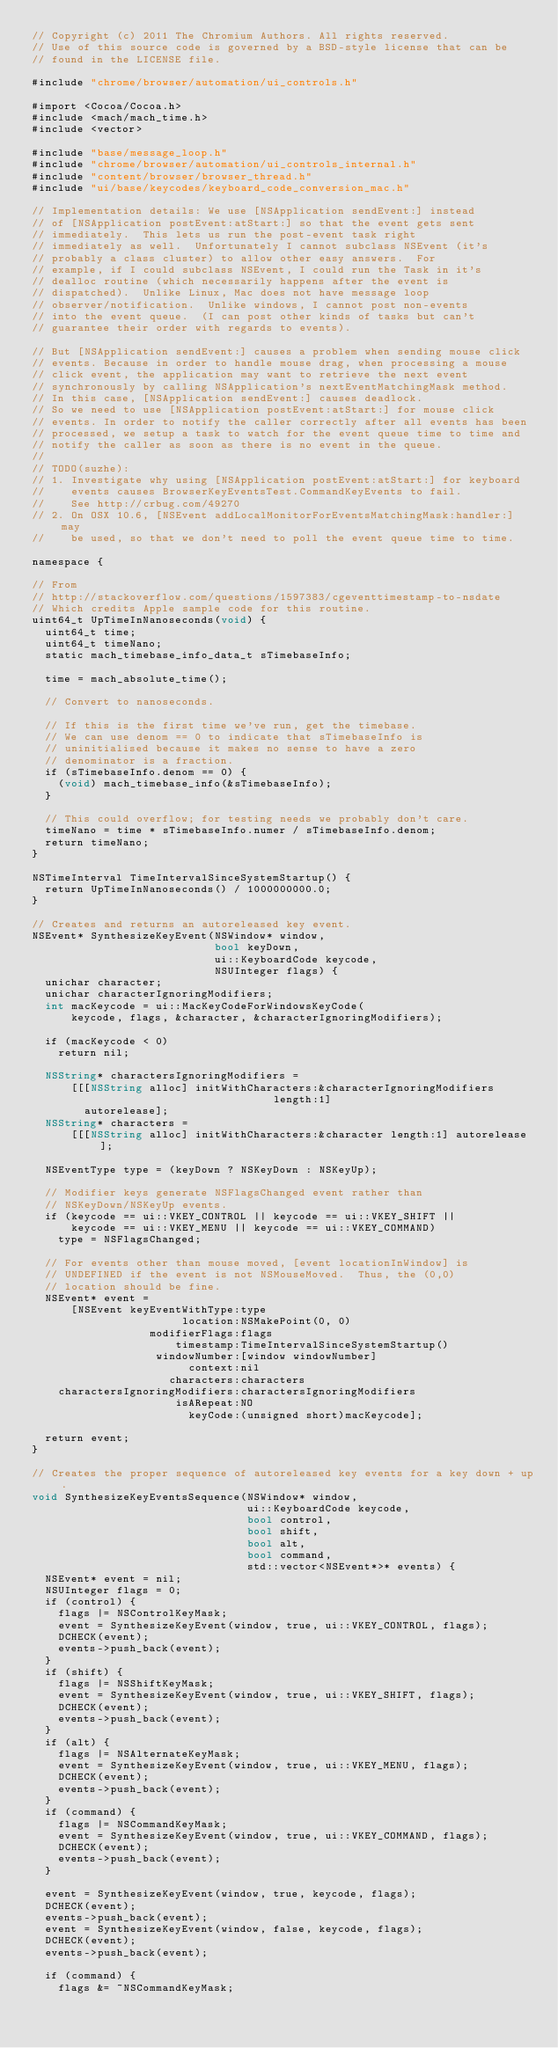Convert code to text. <code><loc_0><loc_0><loc_500><loc_500><_ObjectiveC_>// Copyright (c) 2011 The Chromium Authors. All rights reserved.
// Use of this source code is governed by a BSD-style license that can be
// found in the LICENSE file.

#include "chrome/browser/automation/ui_controls.h"

#import <Cocoa/Cocoa.h>
#include <mach/mach_time.h>
#include <vector>

#include "base/message_loop.h"
#include "chrome/browser/automation/ui_controls_internal.h"
#include "content/browser/browser_thread.h"
#include "ui/base/keycodes/keyboard_code_conversion_mac.h"

// Implementation details: We use [NSApplication sendEvent:] instead
// of [NSApplication postEvent:atStart:] so that the event gets sent
// immediately.  This lets us run the post-event task right
// immediately as well.  Unfortunately I cannot subclass NSEvent (it's
// probably a class cluster) to allow other easy answers.  For
// example, if I could subclass NSEvent, I could run the Task in it's
// dealloc routine (which necessarily happens after the event is
// dispatched).  Unlike Linux, Mac does not have message loop
// observer/notification.  Unlike windows, I cannot post non-events
// into the event queue.  (I can post other kinds of tasks but can't
// guarantee their order with regards to events).

// But [NSApplication sendEvent:] causes a problem when sending mouse click
// events. Because in order to handle mouse drag, when processing a mouse
// click event, the application may want to retrieve the next event
// synchronously by calling NSApplication's nextEventMatchingMask method.
// In this case, [NSApplication sendEvent:] causes deadlock.
// So we need to use [NSApplication postEvent:atStart:] for mouse click
// events. In order to notify the caller correctly after all events has been
// processed, we setup a task to watch for the event queue time to time and
// notify the caller as soon as there is no event in the queue.
//
// TODO(suzhe):
// 1. Investigate why using [NSApplication postEvent:atStart:] for keyboard
//    events causes BrowserKeyEventsTest.CommandKeyEvents to fail.
//    See http://crbug.com/49270
// 2. On OSX 10.6, [NSEvent addLocalMonitorForEventsMatchingMask:handler:] may
//    be used, so that we don't need to poll the event queue time to time.

namespace {

// From
// http://stackoverflow.com/questions/1597383/cgeventtimestamp-to-nsdate
// Which credits Apple sample code for this routine.
uint64_t UpTimeInNanoseconds(void) {
  uint64_t time;
  uint64_t timeNano;
  static mach_timebase_info_data_t sTimebaseInfo;

  time = mach_absolute_time();

  // Convert to nanoseconds.

  // If this is the first time we've run, get the timebase.
  // We can use denom == 0 to indicate that sTimebaseInfo is
  // uninitialised because it makes no sense to have a zero
  // denominator is a fraction.
  if (sTimebaseInfo.denom == 0) {
    (void) mach_timebase_info(&sTimebaseInfo);
  }

  // This could overflow; for testing needs we probably don't care.
  timeNano = time * sTimebaseInfo.numer / sTimebaseInfo.denom;
  return timeNano;
}

NSTimeInterval TimeIntervalSinceSystemStartup() {
  return UpTimeInNanoseconds() / 1000000000.0;
}

// Creates and returns an autoreleased key event.
NSEvent* SynthesizeKeyEvent(NSWindow* window,
                            bool keyDown,
                            ui::KeyboardCode keycode,
                            NSUInteger flags) {
  unichar character;
  unichar characterIgnoringModifiers;
  int macKeycode = ui::MacKeyCodeForWindowsKeyCode(
      keycode, flags, &character, &characterIgnoringModifiers);

  if (macKeycode < 0)
    return nil;

  NSString* charactersIgnoringModifiers =
      [[[NSString alloc] initWithCharacters:&characterIgnoringModifiers
                                     length:1]
        autorelease];
  NSString* characters =
      [[[NSString alloc] initWithCharacters:&character length:1] autorelease];

  NSEventType type = (keyDown ? NSKeyDown : NSKeyUp);

  // Modifier keys generate NSFlagsChanged event rather than
  // NSKeyDown/NSKeyUp events.
  if (keycode == ui::VKEY_CONTROL || keycode == ui::VKEY_SHIFT ||
      keycode == ui::VKEY_MENU || keycode == ui::VKEY_COMMAND)
    type = NSFlagsChanged;

  // For events other than mouse moved, [event locationInWindow] is
  // UNDEFINED if the event is not NSMouseMoved.  Thus, the (0,0)
  // location should be fine.
  NSEvent* event =
      [NSEvent keyEventWithType:type
                       location:NSMakePoint(0, 0)
                  modifierFlags:flags
                      timestamp:TimeIntervalSinceSystemStartup()
                   windowNumber:[window windowNumber]
                        context:nil
                     characters:characters
    charactersIgnoringModifiers:charactersIgnoringModifiers
                      isARepeat:NO
                        keyCode:(unsigned short)macKeycode];

  return event;
}

// Creates the proper sequence of autoreleased key events for a key down + up.
void SynthesizeKeyEventsSequence(NSWindow* window,
                                 ui::KeyboardCode keycode,
                                 bool control,
                                 bool shift,
                                 bool alt,
                                 bool command,
                                 std::vector<NSEvent*>* events) {
  NSEvent* event = nil;
  NSUInteger flags = 0;
  if (control) {
    flags |= NSControlKeyMask;
    event = SynthesizeKeyEvent(window, true, ui::VKEY_CONTROL, flags);
    DCHECK(event);
    events->push_back(event);
  }
  if (shift) {
    flags |= NSShiftKeyMask;
    event = SynthesizeKeyEvent(window, true, ui::VKEY_SHIFT, flags);
    DCHECK(event);
    events->push_back(event);
  }
  if (alt) {
    flags |= NSAlternateKeyMask;
    event = SynthesizeKeyEvent(window, true, ui::VKEY_MENU, flags);
    DCHECK(event);
    events->push_back(event);
  }
  if (command) {
    flags |= NSCommandKeyMask;
    event = SynthesizeKeyEvent(window, true, ui::VKEY_COMMAND, flags);
    DCHECK(event);
    events->push_back(event);
  }

  event = SynthesizeKeyEvent(window, true, keycode, flags);
  DCHECK(event);
  events->push_back(event);
  event = SynthesizeKeyEvent(window, false, keycode, flags);
  DCHECK(event);
  events->push_back(event);

  if (command) {
    flags &= ~NSCommandKeyMask;</code> 